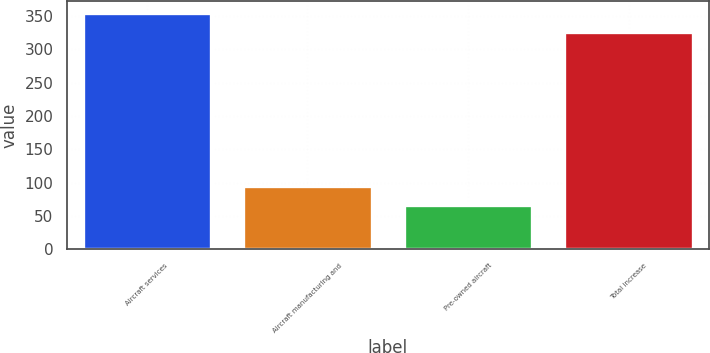Convert chart. <chart><loc_0><loc_0><loc_500><loc_500><bar_chart><fcel>Aircraft services<fcel>Aircraft manufacturing and<fcel>Pre-owned aircraft<fcel>Total increase<nl><fcel>354.6<fcel>95.6<fcel>67<fcel>326<nl></chart> 